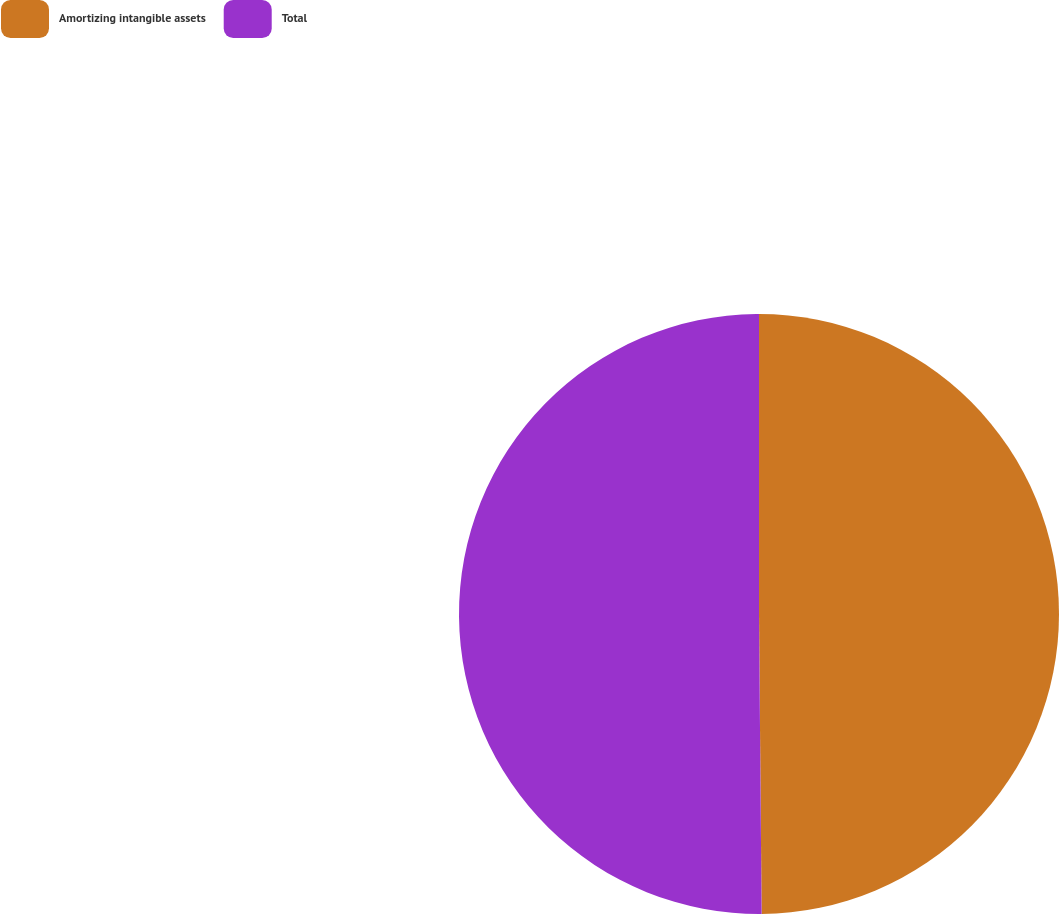Convert chart. <chart><loc_0><loc_0><loc_500><loc_500><pie_chart><fcel>Amortizing intangible assets<fcel>Total<nl><fcel>49.86%<fcel>50.14%<nl></chart> 